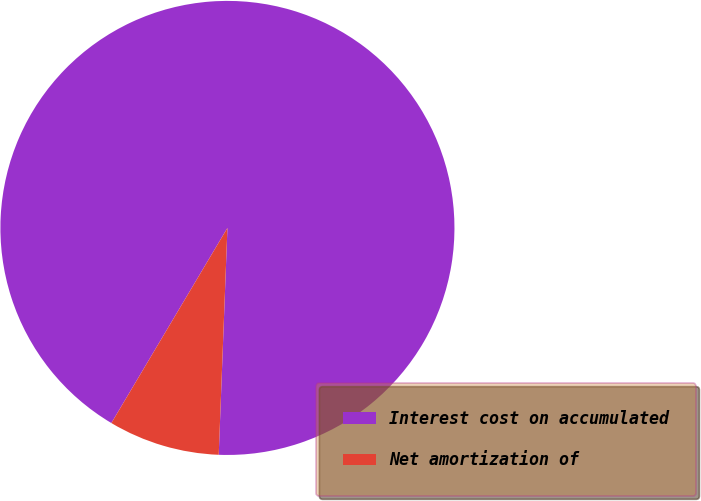<chart> <loc_0><loc_0><loc_500><loc_500><pie_chart><fcel>Interest cost on accumulated<fcel>Net amortization of<nl><fcel>92.07%<fcel>7.93%<nl></chart> 